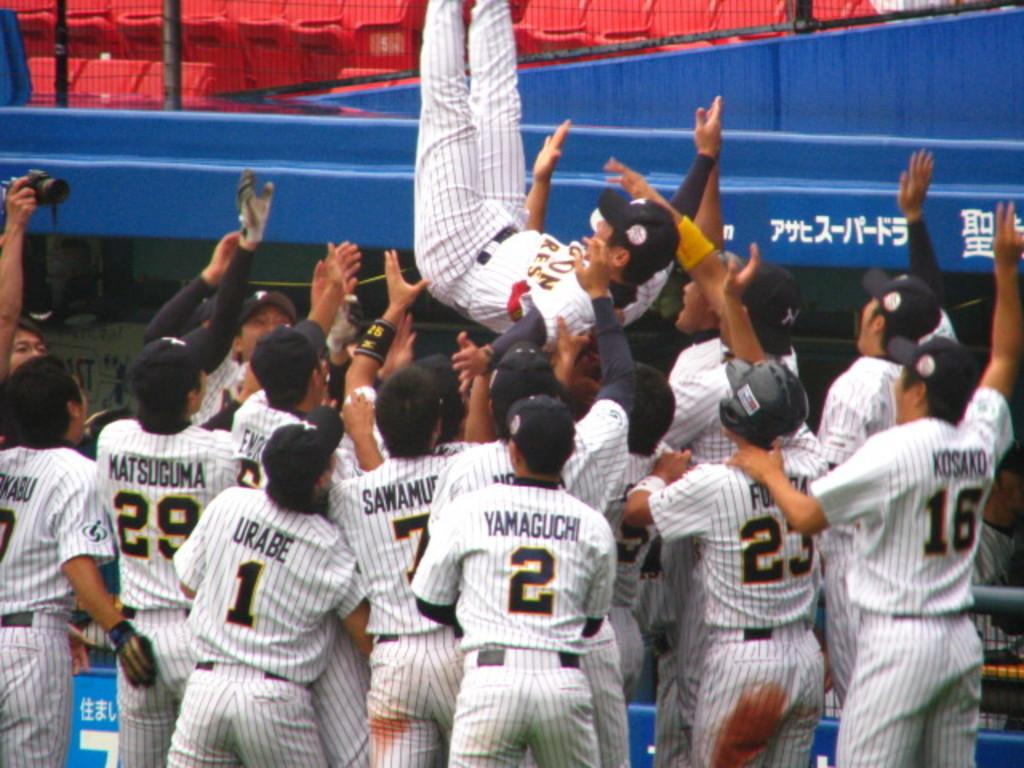<image>
Render a clear and concise summary of the photo. Player number 2 on this baseball team is named Yamaguchi. 